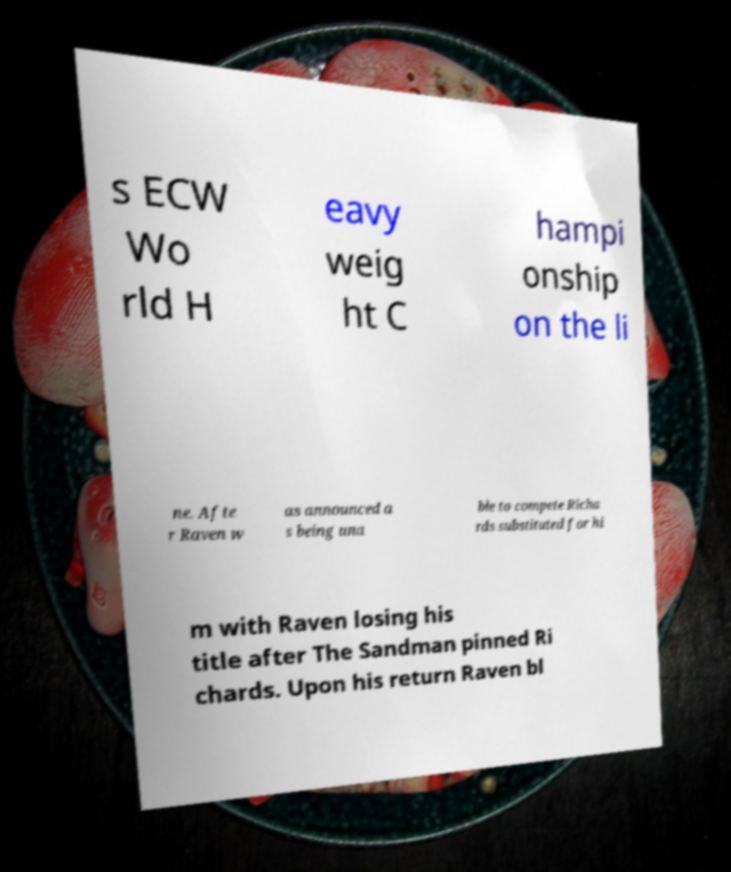What messages or text are displayed in this image? I need them in a readable, typed format. s ECW Wo rld H eavy weig ht C hampi onship on the li ne. Afte r Raven w as announced a s being una ble to compete Richa rds substituted for hi m with Raven losing his title after The Sandman pinned Ri chards. Upon his return Raven bl 